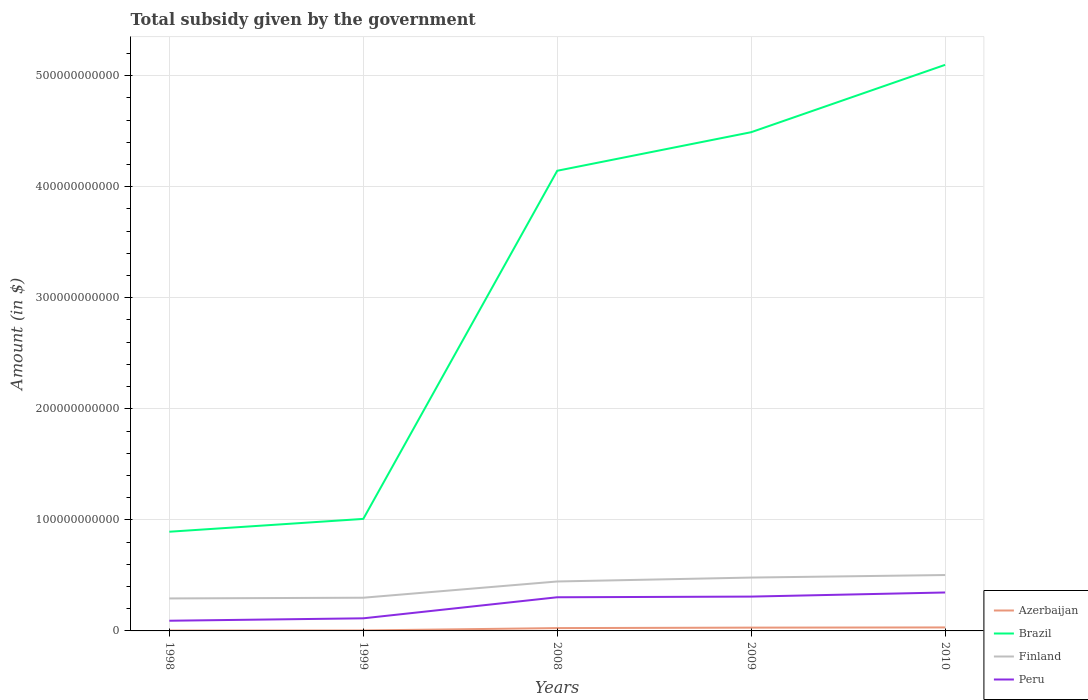How many different coloured lines are there?
Your response must be concise. 4. Across all years, what is the maximum total revenue collected by the government in Peru?
Keep it short and to the point. 9.18e+09. In which year was the total revenue collected by the government in Azerbaijan maximum?
Keep it short and to the point. 1998. What is the total total revenue collected by the government in Finland in the graph?
Give a very brief answer. -1.81e+1. What is the difference between the highest and the second highest total revenue collected by the government in Brazil?
Offer a very short reply. 4.20e+11. Is the total revenue collected by the government in Azerbaijan strictly greater than the total revenue collected by the government in Finland over the years?
Provide a short and direct response. Yes. How many years are there in the graph?
Provide a short and direct response. 5. What is the difference between two consecutive major ticks on the Y-axis?
Your answer should be compact. 1.00e+11. Are the values on the major ticks of Y-axis written in scientific E-notation?
Offer a terse response. No. Does the graph contain any zero values?
Make the answer very short. No. What is the title of the graph?
Your answer should be compact. Total subsidy given by the government. What is the label or title of the Y-axis?
Ensure brevity in your answer.  Amount (in $). What is the Amount (in $) in Azerbaijan in 1998?
Ensure brevity in your answer.  3.57e+08. What is the Amount (in $) of Brazil in 1998?
Your answer should be very brief. 8.93e+1. What is the Amount (in $) of Finland in 1998?
Your answer should be compact. 2.93e+1. What is the Amount (in $) in Peru in 1998?
Your response must be concise. 9.18e+09. What is the Amount (in $) of Azerbaijan in 1999?
Keep it short and to the point. 4.23e+08. What is the Amount (in $) in Brazil in 1999?
Offer a terse response. 1.01e+11. What is the Amount (in $) in Finland in 1999?
Offer a very short reply. 2.99e+1. What is the Amount (in $) in Peru in 1999?
Your answer should be compact. 1.13e+1. What is the Amount (in $) in Azerbaijan in 2008?
Provide a succinct answer. 2.54e+09. What is the Amount (in $) in Brazil in 2008?
Offer a terse response. 4.14e+11. What is the Amount (in $) in Finland in 2008?
Offer a terse response. 4.45e+1. What is the Amount (in $) of Peru in 2008?
Your response must be concise. 3.03e+1. What is the Amount (in $) of Azerbaijan in 2009?
Ensure brevity in your answer.  2.96e+09. What is the Amount (in $) in Brazil in 2009?
Give a very brief answer. 4.49e+11. What is the Amount (in $) in Finland in 2009?
Your response must be concise. 4.80e+1. What is the Amount (in $) of Peru in 2009?
Keep it short and to the point. 3.09e+1. What is the Amount (in $) of Azerbaijan in 2010?
Your answer should be very brief. 3.14e+09. What is the Amount (in $) of Brazil in 2010?
Provide a succinct answer. 5.10e+11. What is the Amount (in $) of Finland in 2010?
Ensure brevity in your answer.  5.03e+1. What is the Amount (in $) of Peru in 2010?
Provide a succinct answer. 3.46e+1. Across all years, what is the maximum Amount (in $) in Azerbaijan?
Your answer should be compact. 3.14e+09. Across all years, what is the maximum Amount (in $) in Brazil?
Ensure brevity in your answer.  5.10e+11. Across all years, what is the maximum Amount (in $) in Finland?
Your answer should be compact. 5.03e+1. Across all years, what is the maximum Amount (in $) in Peru?
Provide a short and direct response. 3.46e+1. Across all years, what is the minimum Amount (in $) in Azerbaijan?
Make the answer very short. 3.57e+08. Across all years, what is the minimum Amount (in $) of Brazil?
Provide a short and direct response. 8.93e+1. Across all years, what is the minimum Amount (in $) in Finland?
Offer a terse response. 2.93e+1. Across all years, what is the minimum Amount (in $) of Peru?
Give a very brief answer. 9.18e+09. What is the total Amount (in $) of Azerbaijan in the graph?
Make the answer very short. 9.43e+09. What is the total Amount (in $) in Brazil in the graph?
Your response must be concise. 1.56e+12. What is the total Amount (in $) of Finland in the graph?
Give a very brief answer. 2.02e+11. What is the total Amount (in $) in Peru in the graph?
Give a very brief answer. 1.16e+11. What is the difference between the Amount (in $) of Azerbaijan in 1998 and that in 1999?
Provide a short and direct response. -6.55e+07. What is the difference between the Amount (in $) in Brazil in 1998 and that in 1999?
Your response must be concise. -1.15e+1. What is the difference between the Amount (in $) of Finland in 1998 and that in 1999?
Offer a very short reply. -6.44e+08. What is the difference between the Amount (in $) of Peru in 1998 and that in 1999?
Make the answer very short. -2.17e+09. What is the difference between the Amount (in $) in Azerbaijan in 1998 and that in 2008?
Ensure brevity in your answer.  -2.19e+09. What is the difference between the Amount (in $) in Brazil in 1998 and that in 2008?
Your answer should be compact. -3.25e+11. What is the difference between the Amount (in $) of Finland in 1998 and that in 2008?
Give a very brief answer. -1.53e+1. What is the difference between the Amount (in $) in Peru in 1998 and that in 2008?
Your answer should be compact. -2.11e+1. What is the difference between the Amount (in $) of Azerbaijan in 1998 and that in 2009?
Make the answer very short. -2.61e+09. What is the difference between the Amount (in $) of Brazil in 1998 and that in 2009?
Keep it short and to the point. -3.60e+11. What is the difference between the Amount (in $) of Finland in 1998 and that in 2009?
Keep it short and to the point. -1.88e+1. What is the difference between the Amount (in $) in Peru in 1998 and that in 2009?
Your response must be concise. -2.17e+1. What is the difference between the Amount (in $) of Azerbaijan in 1998 and that in 2010?
Ensure brevity in your answer.  -2.78e+09. What is the difference between the Amount (in $) in Brazil in 1998 and that in 2010?
Your answer should be compact. -4.20e+11. What is the difference between the Amount (in $) in Finland in 1998 and that in 2010?
Provide a short and direct response. -2.11e+1. What is the difference between the Amount (in $) in Peru in 1998 and that in 2010?
Offer a terse response. -2.54e+1. What is the difference between the Amount (in $) in Azerbaijan in 1999 and that in 2008?
Offer a very short reply. -2.12e+09. What is the difference between the Amount (in $) in Brazil in 1999 and that in 2008?
Keep it short and to the point. -3.13e+11. What is the difference between the Amount (in $) in Finland in 1999 and that in 2008?
Your answer should be very brief. -1.46e+1. What is the difference between the Amount (in $) in Peru in 1999 and that in 2008?
Give a very brief answer. -1.90e+1. What is the difference between the Amount (in $) of Azerbaijan in 1999 and that in 2009?
Give a very brief answer. -2.54e+09. What is the difference between the Amount (in $) in Brazil in 1999 and that in 2009?
Your answer should be very brief. -3.48e+11. What is the difference between the Amount (in $) in Finland in 1999 and that in 2009?
Offer a very short reply. -1.81e+1. What is the difference between the Amount (in $) of Peru in 1999 and that in 2009?
Provide a short and direct response. -1.96e+1. What is the difference between the Amount (in $) in Azerbaijan in 1999 and that in 2010?
Ensure brevity in your answer.  -2.72e+09. What is the difference between the Amount (in $) of Brazil in 1999 and that in 2010?
Your response must be concise. -4.09e+11. What is the difference between the Amount (in $) of Finland in 1999 and that in 2010?
Your answer should be very brief. -2.04e+1. What is the difference between the Amount (in $) of Peru in 1999 and that in 2010?
Your response must be concise. -2.33e+1. What is the difference between the Amount (in $) in Azerbaijan in 2008 and that in 2009?
Provide a succinct answer. -4.20e+08. What is the difference between the Amount (in $) of Brazil in 2008 and that in 2009?
Ensure brevity in your answer.  -3.47e+1. What is the difference between the Amount (in $) in Finland in 2008 and that in 2009?
Offer a very short reply. -3.52e+09. What is the difference between the Amount (in $) of Peru in 2008 and that in 2009?
Your answer should be compact. -6.06e+08. What is the difference between the Amount (in $) in Azerbaijan in 2008 and that in 2010?
Make the answer very short. -5.96e+08. What is the difference between the Amount (in $) in Brazil in 2008 and that in 2010?
Keep it short and to the point. -9.54e+1. What is the difference between the Amount (in $) of Finland in 2008 and that in 2010?
Make the answer very short. -5.80e+09. What is the difference between the Amount (in $) in Peru in 2008 and that in 2010?
Ensure brevity in your answer.  -4.31e+09. What is the difference between the Amount (in $) in Azerbaijan in 2009 and that in 2010?
Provide a succinct answer. -1.76e+08. What is the difference between the Amount (in $) in Brazil in 2009 and that in 2010?
Your response must be concise. -6.06e+1. What is the difference between the Amount (in $) in Finland in 2009 and that in 2010?
Provide a short and direct response. -2.28e+09. What is the difference between the Amount (in $) in Peru in 2009 and that in 2010?
Ensure brevity in your answer.  -3.70e+09. What is the difference between the Amount (in $) in Azerbaijan in 1998 and the Amount (in $) in Brazil in 1999?
Your response must be concise. -1.01e+11. What is the difference between the Amount (in $) in Azerbaijan in 1998 and the Amount (in $) in Finland in 1999?
Offer a terse response. -2.95e+1. What is the difference between the Amount (in $) in Azerbaijan in 1998 and the Amount (in $) in Peru in 1999?
Offer a very short reply. -1.10e+1. What is the difference between the Amount (in $) in Brazil in 1998 and the Amount (in $) in Finland in 1999?
Offer a very short reply. 5.94e+1. What is the difference between the Amount (in $) in Brazil in 1998 and the Amount (in $) in Peru in 1999?
Your answer should be compact. 7.80e+1. What is the difference between the Amount (in $) in Finland in 1998 and the Amount (in $) in Peru in 1999?
Provide a succinct answer. 1.79e+1. What is the difference between the Amount (in $) in Azerbaijan in 1998 and the Amount (in $) in Brazil in 2008?
Keep it short and to the point. -4.14e+11. What is the difference between the Amount (in $) in Azerbaijan in 1998 and the Amount (in $) in Finland in 2008?
Provide a succinct answer. -4.42e+1. What is the difference between the Amount (in $) of Azerbaijan in 1998 and the Amount (in $) of Peru in 2008?
Your response must be concise. -3.00e+1. What is the difference between the Amount (in $) in Brazil in 1998 and the Amount (in $) in Finland in 2008?
Your response must be concise. 4.48e+1. What is the difference between the Amount (in $) of Brazil in 1998 and the Amount (in $) of Peru in 2008?
Make the answer very short. 5.90e+1. What is the difference between the Amount (in $) of Finland in 1998 and the Amount (in $) of Peru in 2008?
Offer a very short reply. -1.05e+09. What is the difference between the Amount (in $) of Azerbaijan in 1998 and the Amount (in $) of Brazil in 2009?
Your answer should be compact. -4.49e+11. What is the difference between the Amount (in $) of Azerbaijan in 1998 and the Amount (in $) of Finland in 2009?
Offer a terse response. -4.77e+1. What is the difference between the Amount (in $) of Azerbaijan in 1998 and the Amount (in $) of Peru in 2009?
Ensure brevity in your answer.  -3.06e+1. What is the difference between the Amount (in $) in Brazil in 1998 and the Amount (in $) in Finland in 2009?
Offer a very short reply. 4.13e+1. What is the difference between the Amount (in $) of Brazil in 1998 and the Amount (in $) of Peru in 2009?
Provide a short and direct response. 5.84e+1. What is the difference between the Amount (in $) in Finland in 1998 and the Amount (in $) in Peru in 2009?
Offer a very short reply. -1.66e+09. What is the difference between the Amount (in $) of Azerbaijan in 1998 and the Amount (in $) of Brazil in 2010?
Make the answer very short. -5.09e+11. What is the difference between the Amount (in $) in Azerbaijan in 1998 and the Amount (in $) in Finland in 2010?
Your response must be concise. -5.00e+1. What is the difference between the Amount (in $) of Azerbaijan in 1998 and the Amount (in $) of Peru in 2010?
Offer a very short reply. -3.43e+1. What is the difference between the Amount (in $) of Brazil in 1998 and the Amount (in $) of Finland in 2010?
Ensure brevity in your answer.  3.90e+1. What is the difference between the Amount (in $) in Brazil in 1998 and the Amount (in $) in Peru in 2010?
Offer a very short reply. 5.47e+1. What is the difference between the Amount (in $) of Finland in 1998 and the Amount (in $) of Peru in 2010?
Give a very brief answer. -5.36e+09. What is the difference between the Amount (in $) in Azerbaijan in 1999 and the Amount (in $) in Brazil in 2008?
Provide a short and direct response. -4.14e+11. What is the difference between the Amount (in $) of Azerbaijan in 1999 and the Amount (in $) of Finland in 2008?
Make the answer very short. -4.41e+1. What is the difference between the Amount (in $) of Azerbaijan in 1999 and the Amount (in $) of Peru in 2008?
Offer a terse response. -2.99e+1. What is the difference between the Amount (in $) of Brazil in 1999 and the Amount (in $) of Finland in 2008?
Ensure brevity in your answer.  5.63e+1. What is the difference between the Amount (in $) in Brazil in 1999 and the Amount (in $) in Peru in 2008?
Your answer should be very brief. 7.06e+1. What is the difference between the Amount (in $) of Finland in 1999 and the Amount (in $) of Peru in 2008?
Make the answer very short. -4.10e+08. What is the difference between the Amount (in $) in Azerbaijan in 1999 and the Amount (in $) in Brazil in 2009?
Keep it short and to the point. -4.49e+11. What is the difference between the Amount (in $) in Azerbaijan in 1999 and the Amount (in $) in Finland in 2009?
Give a very brief answer. -4.76e+1. What is the difference between the Amount (in $) in Azerbaijan in 1999 and the Amount (in $) in Peru in 2009?
Give a very brief answer. -3.05e+1. What is the difference between the Amount (in $) of Brazil in 1999 and the Amount (in $) of Finland in 2009?
Ensure brevity in your answer.  5.28e+1. What is the difference between the Amount (in $) of Brazil in 1999 and the Amount (in $) of Peru in 2009?
Your response must be concise. 7.00e+1. What is the difference between the Amount (in $) in Finland in 1999 and the Amount (in $) in Peru in 2009?
Keep it short and to the point. -1.02e+09. What is the difference between the Amount (in $) in Azerbaijan in 1999 and the Amount (in $) in Brazil in 2010?
Ensure brevity in your answer.  -5.09e+11. What is the difference between the Amount (in $) in Azerbaijan in 1999 and the Amount (in $) in Finland in 2010?
Provide a succinct answer. -4.99e+1. What is the difference between the Amount (in $) in Azerbaijan in 1999 and the Amount (in $) in Peru in 2010?
Your answer should be compact. -3.42e+1. What is the difference between the Amount (in $) in Brazil in 1999 and the Amount (in $) in Finland in 2010?
Your answer should be very brief. 5.05e+1. What is the difference between the Amount (in $) of Brazil in 1999 and the Amount (in $) of Peru in 2010?
Provide a short and direct response. 6.63e+1. What is the difference between the Amount (in $) in Finland in 1999 and the Amount (in $) in Peru in 2010?
Provide a succinct answer. -4.72e+09. What is the difference between the Amount (in $) of Azerbaijan in 2008 and the Amount (in $) of Brazil in 2009?
Your answer should be very brief. -4.47e+11. What is the difference between the Amount (in $) in Azerbaijan in 2008 and the Amount (in $) in Finland in 2009?
Offer a very short reply. -4.55e+1. What is the difference between the Amount (in $) in Azerbaijan in 2008 and the Amount (in $) in Peru in 2009?
Your response must be concise. -2.84e+1. What is the difference between the Amount (in $) of Brazil in 2008 and the Amount (in $) of Finland in 2009?
Keep it short and to the point. 3.66e+11. What is the difference between the Amount (in $) of Brazil in 2008 and the Amount (in $) of Peru in 2009?
Give a very brief answer. 3.83e+11. What is the difference between the Amount (in $) in Finland in 2008 and the Amount (in $) in Peru in 2009?
Ensure brevity in your answer.  1.36e+1. What is the difference between the Amount (in $) of Azerbaijan in 2008 and the Amount (in $) of Brazil in 2010?
Your answer should be compact. -5.07e+11. What is the difference between the Amount (in $) of Azerbaijan in 2008 and the Amount (in $) of Finland in 2010?
Give a very brief answer. -4.78e+1. What is the difference between the Amount (in $) of Azerbaijan in 2008 and the Amount (in $) of Peru in 2010?
Keep it short and to the point. -3.21e+1. What is the difference between the Amount (in $) of Brazil in 2008 and the Amount (in $) of Finland in 2010?
Make the answer very short. 3.64e+11. What is the difference between the Amount (in $) in Brazil in 2008 and the Amount (in $) in Peru in 2010?
Your answer should be compact. 3.80e+11. What is the difference between the Amount (in $) of Finland in 2008 and the Amount (in $) of Peru in 2010?
Your answer should be very brief. 9.90e+09. What is the difference between the Amount (in $) of Azerbaijan in 2009 and the Amount (in $) of Brazil in 2010?
Ensure brevity in your answer.  -5.07e+11. What is the difference between the Amount (in $) of Azerbaijan in 2009 and the Amount (in $) of Finland in 2010?
Offer a very short reply. -4.74e+1. What is the difference between the Amount (in $) of Azerbaijan in 2009 and the Amount (in $) of Peru in 2010?
Offer a very short reply. -3.17e+1. What is the difference between the Amount (in $) of Brazil in 2009 and the Amount (in $) of Finland in 2010?
Offer a terse response. 3.99e+11. What is the difference between the Amount (in $) of Brazil in 2009 and the Amount (in $) of Peru in 2010?
Keep it short and to the point. 4.14e+11. What is the difference between the Amount (in $) of Finland in 2009 and the Amount (in $) of Peru in 2010?
Your answer should be compact. 1.34e+1. What is the average Amount (in $) in Azerbaijan per year?
Keep it short and to the point. 1.89e+09. What is the average Amount (in $) of Brazil per year?
Offer a very short reply. 3.13e+11. What is the average Amount (in $) of Finland per year?
Give a very brief answer. 4.04e+1. What is the average Amount (in $) of Peru per year?
Provide a short and direct response. 2.33e+1. In the year 1998, what is the difference between the Amount (in $) in Azerbaijan and Amount (in $) in Brazil?
Provide a succinct answer. -8.90e+1. In the year 1998, what is the difference between the Amount (in $) in Azerbaijan and Amount (in $) in Finland?
Give a very brief answer. -2.89e+1. In the year 1998, what is the difference between the Amount (in $) of Azerbaijan and Amount (in $) of Peru?
Your response must be concise. -8.82e+09. In the year 1998, what is the difference between the Amount (in $) of Brazil and Amount (in $) of Finland?
Offer a terse response. 6.01e+1. In the year 1998, what is the difference between the Amount (in $) in Brazil and Amount (in $) in Peru?
Ensure brevity in your answer.  8.01e+1. In the year 1998, what is the difference between the Amount (in $) of Finland and Amount (in $) of Peru?
Offer a terse response. 2.01e+1. In the year 1999, what is the difference between the Amount (in $) in Azerbaijan and Amount (in $) in Brazil?
Your answer should be very brief. -1.00e+11. In the year 1999, what is the difference between the Amount (in $) of Azerbaijan and Amount (in $) of Finland?
Provide a short and direct response. -2.95e+1. In the year 1999, what is the difference between the Amount (in $) in Azerbaijan and Amount (in $) in Peru?
Keep it short and to the point. -1.09e+1. In the year 1999, what is the difference between the Amount (in $) in Brazil and Amount (in $) in Finland?
Make the answer very short. 7.10e+1. In the year 1999, what is the difference between the Amount (in $) in Brazil and Amount (in $) in Peru?
Your answer should be compact. 8.95e+1. In the year 1999, what is the difference between the Amount (in $) of Finland and Amount (in $) of Peru?
Offer a terse response. 1.85e+1. In the year 2008, what is the difference between the Amount (in $) in Azerbaijan and Amount (in $) in Brazil?
Offer a terse response. -4.12e+11. In the year 2008, what is the difference between the Amount (in $) of Azerbaijan and Amount (in $) of Finland?
Offer a very short reply. -4.20e+1. In the year 2008, what is the difference between the Amount (in $) in Azerbaijan and Amount (in $) in Peru?
Your response must be concise. -2.78e+1. In the year 2008, what is the difference between the Amount (in $) in Brazil and Amount (in $) in Finland?
Give a very brief answer. 3.70e+11. In the year 2008, what is the difference between the Amount (in $) in Brazil and Amount (in $) in Peru?
Offer a very short reply. 3.84e+11. In the year 2008, what is the difference between the Amount (in $) of Finland and Amount (in $) of Peru?
Your answer should be compact. 1.42e+1. In the year 2009, what is the difference between the Amount (in $) in Azerbaijan and Amount (in $) in Brazil?
Keep it short and to the point. -4.46e+11. In the year 2009, what is the difference between the Amount (in $) of Azerbaijan and Amount (in $) of Finland?
Ensure brevity in your answer.  -4.51e+1. In the year 2009, what is the difference between the Amount (in $) of Azerbaijan and Amount (in $) of Peru?
Your answer should be compact. -2.80e+1. In the year 2009, what is the difference between the Amount (in $) in Brazil and Amount (in $) in Finland?
Provide a short and direct response. 4.01e+11. In the year 2009, what is the difference between the Amount (in $) in Brazil and Amount (in $) in Peru?
Ensure brevity in your answer.  4.18e+11. In the year 2009, what is the difference between the Amount (in $) of Finland and Amount (in $) of Peru?
Make the answer very short. 1.71e+1. In the year 2010, what is the difference between the Amount (in $) in Azerbaijan and Amount (in $) in Brazil?
Give a very brief answer. -5.07e+11. In the year 2010, what is the difference between the Amount (in $) in Azerbaijan and Amount (in $) in Finland?
Ensure brevity in your answer.  -4.72e+1. In the year 2010, what is the difference between the Amount (in $) in Azerbaijan and Amount (in $) in Peru?
Give a very brief answer. -3.15e+1. In the year 2010, what is the difference between the Amount (in $) of Brazil and Amount (in $) of Finland?
Give a very brief answer. 4.59e+11. In the year 2010, what is the difference between the Amount (in $) of Brazil and Amount (in $) of Peru?
Give a very brief answer. 4.75e+11. In the year 2010, what is the difference between the Amount (in $) in Finland and Amount (in $) in Peru?
Offer a terse response. 1.57e+1. What is the ratio of the Amount (in $) in Azerbaijan in 1998 to that in 1999?
Your answer should be compact. 0.85. What is the ratio of the Amount (in $) in Brazil in 1998 to that in 1999?
Keep it short and to the point. 0.89. What is the ratio of the Amount (in $) in Finland in 1998 to that in 1999?
Make the answer very short. 0.98. What is the ratio of the Amount (in $) of Peru in 1998 to that in 1999?
Your answer should be compact. 0.81. What is the ratio of the Amount (in $) in Azerbaijan in 1998 to that in 2008?
Make the answer very short. 0.14. What is the ratio of the Amount (in $) of Brazil in 1998 to that in 2008?
Your response must be concise. 0.22. What is the ratio of the Amount (in $) in Finland in 1998 to that in 2008?
Your answer should be compact. 0.66. What is the ratio of the Amount (in $) in Peru in 1998 to that in 2008?
Provide a succinct answer. 0.3. What is the ratio of the Amount (in $) of Azerbaijan in 1998 to that in 2009?
Provide a succinct answer. 0.12. What is the ratio of the Amount (in $) in Brazil in 1998 to that in 2009?
Your response must be concise. 0.2. What is the ratio of the Amount (in $) in Finland in 1998 to that in 2009?
Keep it short and to the point. 0.61. What is the ratio of the Amount (in $) in Peru in 1998 to that in 2009?
Offer a terse response. 0.3. What is the ratio of the Amount (in $) in Azerbaijan in 1998 to that in 2010?
Your response must be concise. 0.11. What is the ratio of the Amount (in $) in Brazil in 1998 to that in 2010?
Make the answer very short. 0.18. What is the ratio of the Amount (in $) in Finland in 1998 to that in 2010?
Ensure brevity in your answer.  0.58. What is the ratio of the Amount (in $) in Peru in 1998 to that in 2010?
Offer a terse response. 0.27. What is the ratio of the Amount (in $) of Azerbaijan in 1999 to that in 2008?
Your response must be concise. 0.17. What is the ratio of the Amount (in $) of Brazil in 1999 to that in 2008?
Give a very brief answer. 0.24. What is the ratio of the Amount (in $) of Finland in 1999 to that in 2008?
Give a very brief answer. 0.67. What is the ratio of the Amount (in $) in Peru in 1999 to that in 2008?
Give a very brief answer. 0.37. What is the ratio of the Amount (in $) of Azerbaijan in 1999 to that in 2009?
Your response must be concise. 0.14. What is the ratio of the Amount (in $) in Brazil in 1999 to that in 2009?
Make the answer very short. 0.22. What is the ratio of the Amount (in $) of Finland in 1999 to that in 2009?
Your answer should be very brief. 0.62. What is the ratio of the Amount (in $) of Peru in 1999 to that in 2009?
Keep it short and to the point. 0.37. What is the ratio of the Amount (in $) in Azerbaijan in 1999 to that in 2010?
Ensure brevity in your answer.  0.13. What is the ratio of the Amount (in $) of Brazil in 1999 to that in 2010?
Make the answer very short. 0.2. What is the ratio of the Amount (in $) of Finland in 1999 to that in 2010?
Offer a terse response. 0.59. What is the ratio of the Amount (in $) in Peru in 1999 to that in 2010?
Provide a short and direct response. 0.33. What is the ratio of the Amount (in $) of Azerbaijan in 2008 to that in 2009?
Keep it short and to the point. 0.86. What is the ratio of the Amount (in $) in Brazil in 2008 to that in 2009?
Provide a short and direct response. 0.92. What is the ratio of the Amount (in $) in Finland in 2008 to that in 2009?
Your response must be concise. 0.93. What is the ratio of the Amount (in $) of Peru in 2008 to that in 2009?
Offer a very short reply. 0.98. What is the ratio of the Amount (in $) of Azerbaijan in 2008 to that in 2010?
Give a very brief answer. 0.81. What is the ratio of the Amount (in $) of Brazil in 2008 to that in 2010?
Keep it short and to the point. 0.81. What is the ratio of the Amount (in $) in Finland in 2008 to that in 2010?
Give a very brief answer. 0.88. What is the ratio of the Amount (in $) of Peru in 2008 to that in 2010?
Offer a terse response. 0.88. What is the ratio of the Amount (in $) of Azerbaijan in 2009 to that in 2010?
Ensure brevity in your answer.  0.94. What is the ratio of the Amount (in $) of Brazil in 2009 to that in 2010?
Offer a very short reply. 0.88. What is the ratio of the Amount (in $) in Finland in 2009 to that in 2010?
Ensure brevity in your answer.  0.95. What is the ratio of the Amount (in $) in Peru in 2009 to that in 2010?
Offer a terse response. 0.89. What is the difference between the highest and the second highest Amount (in $) in Azerbaijan?
Your answer should be very brief. 1.76e+08. What is the difference between the highest and the second highest Amount (in $) in Brazil?
Ensure brevity in your answer.  6.06e+1. What is the difference between the highest and the second highest Amount (in $) in Finland?
Ensure brevity in your answer.  2.28e+09. What is the difference between the highest and the second highest Amount (in $) of Peru?
Make the answer very short. 3.70e+09. What is the difference between the highest and the lowest Amount (in $) in Azerbaijan?
Make the answer very short. 2.78e+09. What is the difference between the highest and the lowest Amount (in $) in Brazil?
Give a very brief answer. 4.20e+11. What is the difference between the highest and the lowest Amount (in $) in Finland?
Make the answer very short. 2.11e+1. What is the difference between the highest and the lowest Amount (in $) in Peru?
Your answer should be very brief. 2.54e+1. 